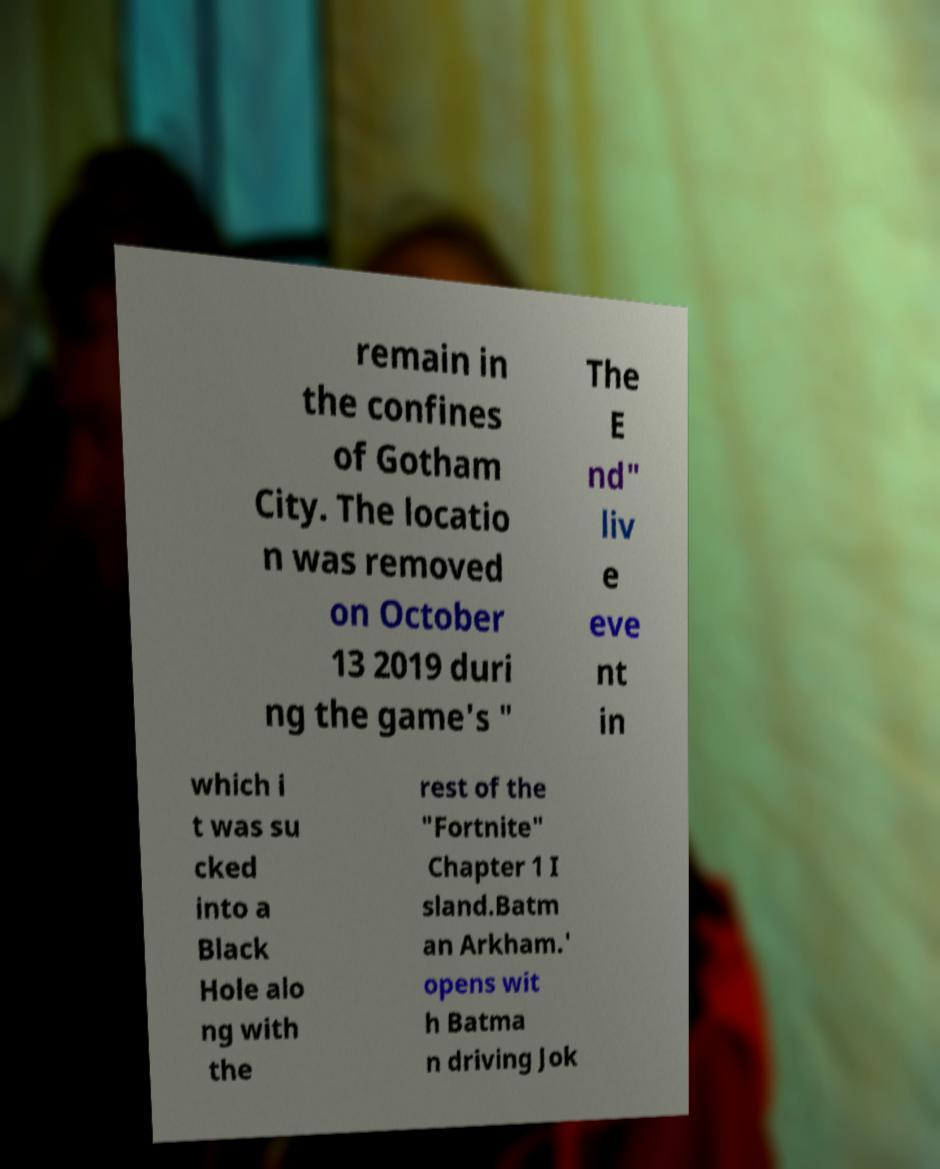Please read and relay the text visible in this image. What does it say? remain in the confines of Gotham City. The locatio n was removed on October 13 2019 duri ng the game's " The E nd" liv e eve nt in which i t was su cked into a Black Hole alo ng with the rest of the "Fortnite" Chapter 1 I sland.Batm an Arkham.' opens wit h Batma n driving Jok 